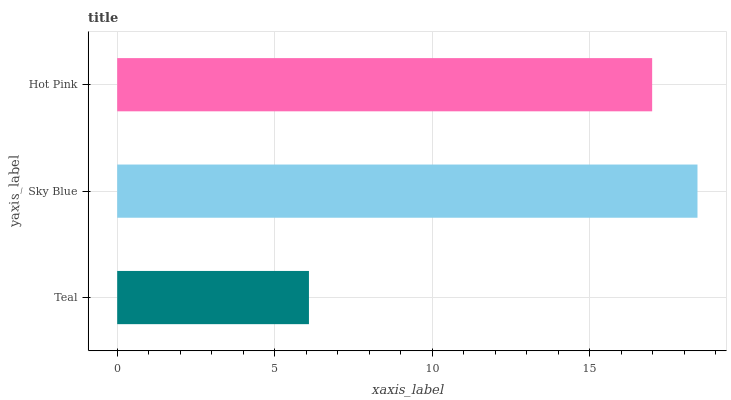Is Teal the minimum?
Answer yes or no. Yes. Is Sky Blue the maximum?
Answer yes or no. Yes. Is Hot Pink the minimum?
Answer yes or no. No. Is Hot Pink the maximum?
Answer yes or no. No. Is Sky Blue greater than Hot Pink?
Answer yes or no. Yes. Is Hot Pink less than Sky Blue?
Answer yes or no. Yes. Is Hot Pink greater than Sky Blue?
Answer yes or no. No. Is Sky Blue less than Hot Pink?
Answer yes or no. No. Is Hot Pink the high median?
Answer yes or no. Yes. Is Hot Pink the low median?
Answer yes or no. Yes. Is Teal the high median?
Answer yes or no. No. Is Teal the low median?
Answer yes or no. No. 